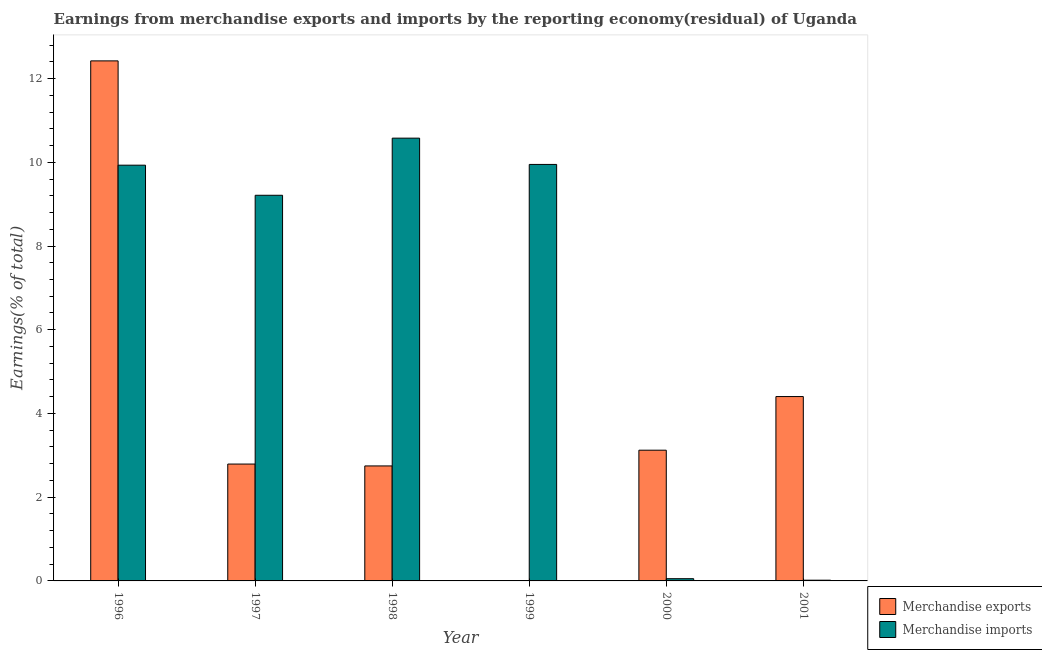How many different coloured bars are there?
Offer a terse response. 2. Are the number of bars on each tick of the X-axis equal?
Your answer should be compact. No. How many bars are there on the 4th tick from the left?
Provide a succinct answer. 1. What is the earnings from merchandise exports in 2001?
Your response must be concise. 4.4. Across all years, what is the maximum earnings from merchandise imports?
Keep it short and to the point. 10.58. Across all years, what is the minimum earnings from merchandise imports?
Keep it short and to the point. 0.02. In which year was the earnings from merchandise exports maximum?
Provide a short and direct response. 1996. What is the total earnings from merchandise exports in the graph?
Offer a very short reply. 25.49. What is the difference between the earnings from merchandise exports in 1996 and that in 1998?
Your response must be concise. 9.68. What is the difference between the earnings from merchandise exports in 2000 and the earnings from merchandise imports in 1997?
Offer a terse response. 0.33. What is the average earnings from merchandise exports per year?
Your answer should be very brief. 4.25. In the year 2000, what is the difference between the earnings from merchandise imports and earnings from merchandise exports?
Your answer should be compact. 0. In how many years, is the earnings from merchandise imports greater than 10.8 %?
Ensure brevity in your answer.  0. What is the ratio of the earnings from merchandise exports in 1996 to that in 2001?
Your answer should be compact. 2.82. What is the difference between the highest and the second highest earnings from merchandise imports?
Offer a terse response. 0.63. What is the difference between the highest and the lowest earnings from merchandise exports?
Keep it short and to the point. 12.42. How many bars are there?
Ensure brevity in your answer.  11. Are the values on the major ticks of Y-axis written in scientific E-notation?
Your answer should be compact. No. Where does the legend appear in the graph?
Offer a very short reply. Bottom right. What is the title of the graph?
Your response must be concise. Earnings from merchandise exports and imports by the reporting economy(residual) of Uganda. What is the label or title of the X-axis?
Offer a very short reply. Year. What is the label or title of the Y-axis?
Offer a terse response. Earnings(% of total). What is the Earnings(% of total) of Merchandise exports in 1996?
Give a very brief answer. 12.42. What is the Earnings(% of total) of Merchandise imports in 1996?
Keep it short and to the point. 9.93. What is the Earnings(% of total) in Merchandise exports in 1997?
Offer a terse response. 2.79. What is the Earnings(% of total) of Merchandise imports in 1997?
Offer a very short reply. 9.21. What is the Earnings(% of total) of Merchandise exports in 1998?
Your response must be concise. 2.75. What is the Earnings(% of total) of Merchandise imports in 1998?
Keep it short and to the point. 10.58. What is the Earnings(% of total) of Merchandise imports in 1999?
Provide a succinct answer. 9.95. What is the Earnings(% of total) in Merchandise exports in 2000?
Give a very brief answer. 3.12. What is the Earnings(% of total) in Merchandise imports in 2000?
Your response must be concise. 0.05. What is the Earnings(% of total) of Merchandise exports in 2001?
Provide a succinct answer. 4.4. What is the Earnings(% of total) of Merchandise imports in 2001?
Provide a succinct answer. 0.02. Across all years, what is the maximum Earnings(% of total) of Merchandise exports?
Offer a very short reply. 12.42. Across all years, what is the maximum Earnings(% of total) of Merchandise imports?
Your answer should be compact. 10.58. Across all years, what is the minimum Earnings(% of total) in Merchandise exports?
Your response must be concise. 0. Across all years, what is the minimum Earnings(% of total) of Merchandise imports?
Keep it short and to the point. 0.02. What is the total Earnings(% of total) in Merchandise exports in the graph?
Offer a very short reply. 25.49. What is the total Earnings(% of total) of Merchandise imports in the graph?
Offer a very short reply. 39.74. What is the difference between the Earnings(% of total) of Merchandise exports in 1996 and that in 1997?
Your response must be concise. 9.63. What is the difference between the Earnings(% of total) in Merchandise imports in 1996 and that in 1997?
Ensure brevity in your answer.  0.72. What is the difference between the Earnings(% of total) of Merchandise exports in 1996 and that in 1998?
Make the answer very short. 9.68. What is the difference between the Earnings(% of total) in Merchandise imports in 1996 and that in 1998?
Ensure brevity in your answer.  -0.65. What is the difference between the Earnings(% of total) of Merchandise imports in 1996 and that in 1999?
Make the answer very short. -0.02. What is the difference between the Earnings(% of total) in Merchandise exports in 1996 and that in 2000?
Your answer should be compact. 9.3. What is the difference between the Earnings(% of total) of Merchandise imports in 1996 and that in 2000?
Offer a terse response. 9.88. What is the difference between the Earnings(% of total) of Merchandise exports in 1996 and that in 2001?
Keep it short and to the point. 8.02. What is the difference between the Earnings(% of total) in Merchandise imports in 1996 and that in 2001?
Offer a very short reply. 9.91. What is the difference between the Earnings(% of total) in Merchandise exports in 1997 and that in 1998?
Make the answer very short. 0.04. What is the difference between the Earnings(% of total) in Merchandise imports in 1997 and that in 1998?
Keep it short and to the point. -1.36. What is the difference between the Earnings(% of total) in Merchandise imports in 1997 and that in 1999?
Make the answer very short. -0.74. What is the difference between the Earnings(% of total) of Merchandise exports in 1997 and that in 2000?
Keep it short and to the point. -0.33. What is the difference between the Earnings(% of total) in Merchandise imports in 1997 and that in 2000?
Ensure brevity in your answer.  9.16. What is the difference between the Earnings(% of total) of Merchandise exports in 1997 and that in 2001?
Your response must be concise. -1.61. What is the difference between the Earnings(% of total) of Merchandise imports in 1997 and that in 2001?
Offer a terse response. 9.19. What is the difference between the Earnings(% of total) in Merchandise imports in 1998 and that in 1999?
Your response must be concise. 0.63. What is the difference between the Earnings(% of total) in Merchandise exports in 1998 and that in 2000?
Provide a short and direct response. -0.38. What is the difference between the Earnings(% of total) of Merchandise imports in 1998 and that in 2000?
Provide a succinct answer. 10.52. What is the difference between the Earnings(% of total) of Merchandise exports in 1998 and that in 2001?
Your response must be concise. -1.66. What is the difference between the Earnings(% of total) of Merchandise imports in 1998 and that in 2001?
Your answer should be very brief. 10.56. What is the difference between the Earnings(% of total) of Merchandise imports in 1999 and that in 2000?
Provide a short and direct response. 9.9. What is the difference between the Earnings(% of total) of Merchandise imports in 1999 and that in 2001?
Offer a very short reply. 9.93. What is the difference between the Earnings(% of total) of Merchandise exports in 2000 and that in 2001?
Ensure brevity in your answer.  -1.28. What is the difference between the Earnings(% of total) in Merchandise imports in 2000 and that in 2001?
Make the answer very short. 0.04. What is the difference between the Earnings(% of total) in Merchandise exports in 1996 and the Earnings(% of total) in Merchandise imports in 1997?
Provide a succinct answer. 3.21. What is the difference between the Earnings(% of total) in Merchandise exports in 1996 and the Earnings(% of total) in Merchandise imports in 1998?
Your response must be concise. 1.85. What is the difference between the Earnings(% of total) in Merchandise exports in 1996 and the Earnings(% of total) in Merchandise imports in 1999?
Provide a short and direct response. 2.47. What is the difference between the Earnings(% of total) of Merchandise exports in 1996 and the Earnings(% of total) of Merchandise imports in 2000?
Provide a succinct answer. 12.37. What is the difference between the Earnings(% of total) of Merchandise exports in 1996 and the Earnings(% of total) of Merchandise imports in 2001?
Keep it short and to the point. 12.4. What is the difference between the Earnings(% of total) in Merchandise exports in 1997 and the Earnings(% of total) in Merchandise imports in 1998?
Provide a succinct answer. -7.78. What is the difference between the Earnings(% of total) in Merchandise exports in 1997 and the Earnings(% of total) in Merchandise imports in 1999?
Give a very brief answer. -7.16. What is the difference between the Earnings(% of total) of Merchandise exports in 1997 and the Earnings(% of total) of Merchandise imports in 2000?
Your answer should be compact. 2.74. What is the difference between the Earnings(% of total) of Merchandise exports in 1997 and the Earnings(% of total) of Merchandise imports in 2001?
Offer a terse response. 2.77. What is the difference between the Earnings(% of total) in Merchandise exports in 1998 and the Earnings(% of total) in Merchandise imports in 1999?
Your answer should be compact. -7.2. What is the difference between the Earnings(% of total) in Merchandise exports in 1998 and the Earnings(% of total) in Merchandise imports in 2000?
Offer a very short reply. 2.69. What is the difference between the Earnings(% of total) in Merchandise exports in 1998 and the Earnings(% of total) in Merchandise imports in 2001?
Your response must be concise. 2.73. What is the difference between the Earnings(% of total) in Merchandise exports in 2000 and the Earnings(% of total) in Merchandise imports in 2001?
Provide a succinct answer. 3.11. What is the average Earnings(% of total) of Merchandise exports per year?
Keep it short and to the point. 4.25. What is the average Earnings(% of total) in Merchandise imports per year?
Your answer should be very brief. 6.62. In the year 1996, what is the difference between the Earnings(% of total) of Merchandise exports and Earnings(% of total) of Merchandise imports?
Your response must be concise. 2.49. In the year 1997, what is the difference between the Earnings(% of total) in Merchandise exports and Earnings(% of total) in Merchandise imports?
Give a very brief answer. -6.42. In the year 1998, what is the difference between the Earnings(% of total) of Merchandise exports and Earnings(% of total) of Merchandise imports?
Provide a succinct answer. -7.83. In the year 2000, what is the difference between the Earnings(% of total) in Merchandise exports and Earnings(% of total) in Merchandise imports?
Offer a terse response. 3.07. In the year 2001, what is the difference between the Earnings(% of total) of Merchandise exports and Earnings(% of total) of Merchandise imports?
Keep it short and to the point. 4.39. What is the ratio of the Earnings(% of total) of Merchandise exports in 1996 to that in 1997?
Ensure brevity in your answer.  4.45. What is the ratio of the Earnings(% of total) of Merchandise imports in 1996 to that in 1997?
Keep it short and to the point. 1.08. What is the ratio of the Earnings(% of total) in Merchandise exports in 1996 to that in 1998?
Keep it short and to the point. 4.52. What is the ratio of the Earnings(% of total) in Merchandise imports in 1996 to that in 1998?
Give a very brief answer. 0.94. What is the ratio of the Earnings(% of total) of Merchandise exports in 1996 to that in 2000?
Your answer should be very brief. 3.98. What is the ratio of the Earnings(% of total) in Merchandise imports in 1996 to that in 2000?
Give a very brief answer. 186.51. What is the ratio of the Earnings(% of total) of Merchandise exports in 1996 to that in 2001?
Ensure brevity in your answer.  2.82. What is the ratio of the Earnings(% of total) of Merchandise imports in 1996 to that in 2001?
Ensure brevity in your answer.  571.16. What is the ratio of the Earnings(% of total) in Merchandise exports in 1997 to that in 1998?
Offer a terse response. 1.02. What is the ratio of the Earnings(% of total) in Merchandise imports in 1997 to that in 1998?
Give a very brief answer. 0.87. What is the ratio of the Earnings(% of total) in Merchandise imports in 1997 to that in 1999?
Offer a terse response. 0.93. What is the ratio of the Earnings(% of total) in Merchandise exports in 1997 to that in 2000?
Keep it short and to the point. 0.89. What is the ratio of the Earnings(% of total) in Merchandise imports in 1997 to that in 2000?
Your response must be concise. 173.01. What is the ratio of the Earnings(% of total) in Merchandise exports in 1997 to that in 2001?
Give a very brief answer. 0.63. What is the ratio of the Earnings(% of total) in Merchandise imports in 1997 to that in 2001?
Your response must be concise. 529.81. What is the ratio of the Earnings(% of total) of Merchandise imports in 1998 to that in 1999?
Your answer should be very brief. 1.06. What is the ratio of the Earnings(% of total) of Merchandise exports in 1998 to that in 2000?
Give a very brief answer. 0.88. What is the ratio of the Earnings(% of total) in Merchandise imports in 1998 to that in 2000?
Give a very brief answer. 198.64. What is the ratio of the Earnings(% of total) in Merchandise exports in 1998 to that in 2001?
Give a very brief answer. 0.62. What is the ratio of the Earnings(% of total) of Merchandise imports in 1998 to that in 2001?
Ensure brevity in your answer.  608.3. What is the ratio of the Earnings(% of total) of Merchandise imports in 1999 to that in 2000?
Your response must be concise. 186.85. What is the ratio of the Earnings(% of total) in Merchandise imports in 1999 to that in 2001?
Make the answer very short. 572.2. What is the ratio of the Earnings(% of total) in Merchandise exports in 2000 to that in 2001?
Make the answer very short. 0.71. What is the ratio of the Earnings(% of total) in Merchandise imports in 2000 to that in 2001?
Provide a short and direct response. 3.06. What is the difference between the highest and the second highest Earnings(% of total) in Merchandise exports?
Provide a succinct answer. 8.02. What is the difference between the highest and the second highest Earnings(% of total) of Merchandise imports?
Your answer should be very brief. 0.63. What is the difference between the highest and the lowest Earnings(% of total) of Merchandise exports?
Keep it short and to the point. 12.42. What is the difference between the highest and the lowest Earnings(% of total) in Merchandise imports?
Provide a succinct answer. 10.56. 